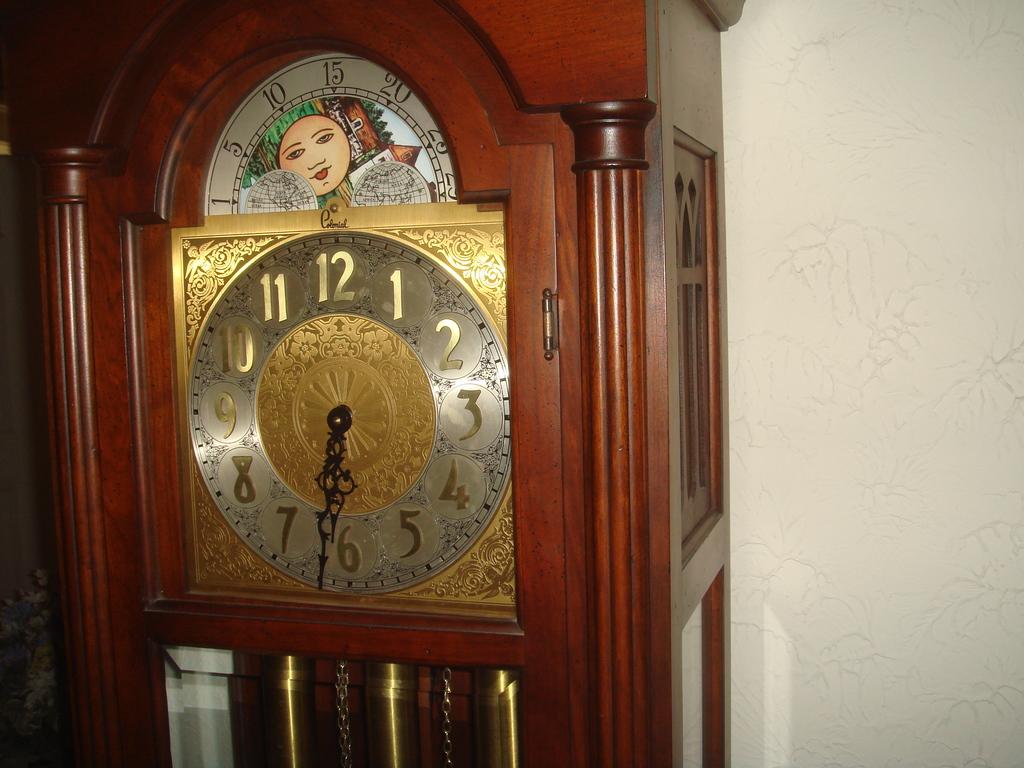What time does the clock say?
Offer a terse response. 6:32. What numbers are on the clock above the 12?
Your response must be concise. 15. 